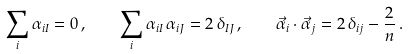<formula> <loc_0><loc_0><loc_500><loc_500>\sum _ { i } \alpha _ { i I } = 0 \, , \quad \sum _ { i } \alpha _ { i I } \, \alpha _ { i J } = 2 \, \delta _ { I J } \, , \quad \vec { \alpha } _ { i } \cdot \vec { \alpha } _ { j } = 2 \, \delta _ { i j } - \frac { 2 } { n } \, .</formula> 